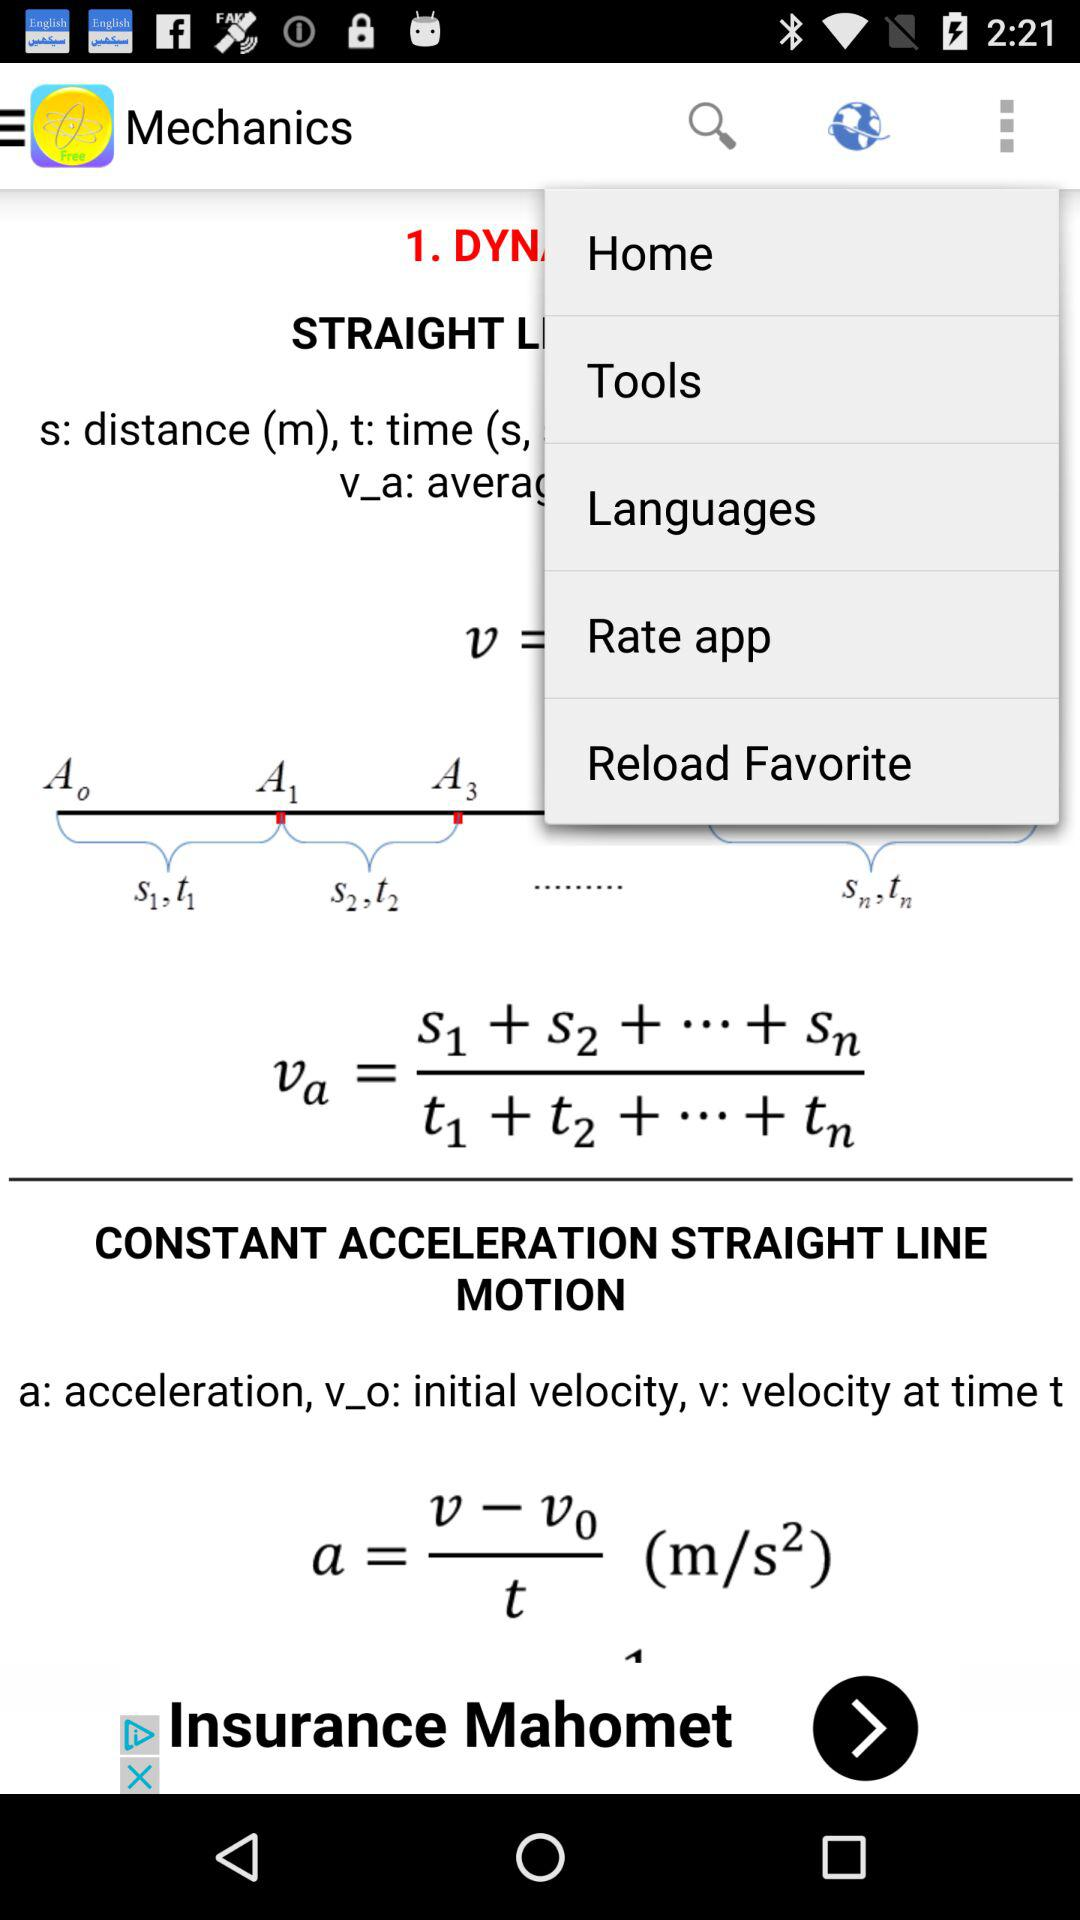What is the app name? The app name is "Mechanics". 